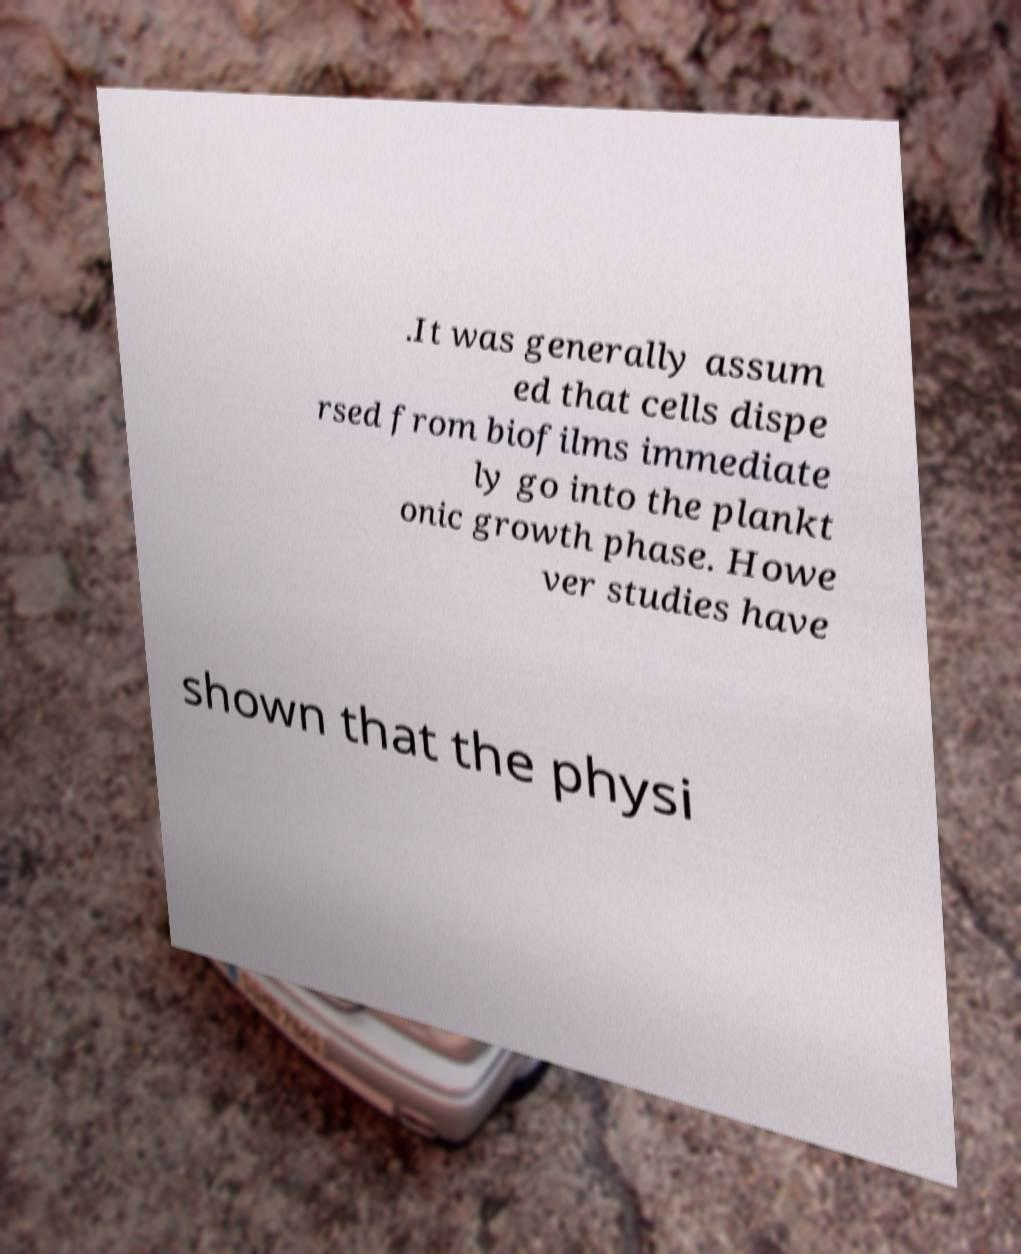I need the written content from this picture converted into text. Can you do that? .It was generally assum ed that cells dispe rsed from biofilms immediate ly go into the plankt onic growth phase. Howe ver studies have shown that the physi 